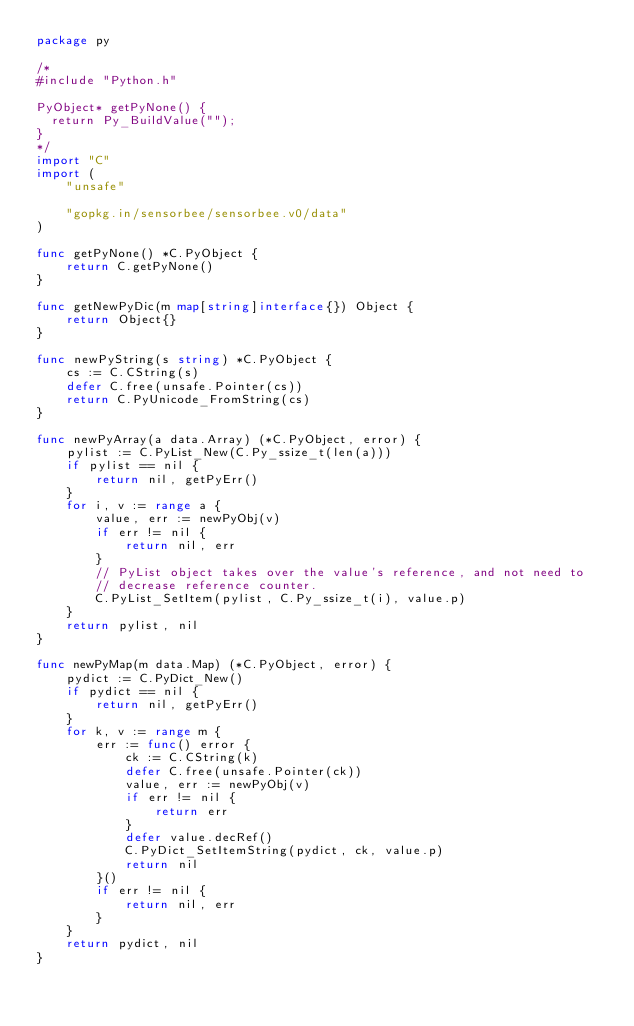<code> <loc_0><loc_0><loc_500><loc_500><_Go_>package py

/*
#include "Python.h"

PyObject* getPyNone() {
  return Py_BuildValue("");
}
*/
import "C"
import (
	"unsafe"

	"gopkg.in/sensorbee/sensorbee.v0/data"
)

func getPyNone() *C.PyObject {
	return C.getPyNone()
}

func getNewPyDic(m map[string]interface{}) Object {
	return Object{}
}

func newPyString(s string) *C.PyObject {
	cs := C.CString(s)
	defer C.free(unsafe.Pointer(cs))
	return C.PyUnicode_FromString(cs)
}

func newPyArray(a data.Array) (*C.PyObject, error) {
	pylist := C.PyList_New(C.Py_ssize_t(len(a)))
	if pylist == nil {
		return nil, getPyErr()
	}
	for i, v := range a {
		value, err := newPyObj(v)
		if err != nil {
			return nil, err
		}
		// PyList object takes over the value's reference, and not need to
		// decrease reference counter.
		C.PyList_SetItem(pylist, C.Py_ssize_t(i), value.p)
	}
	return pylist, nil
}

func newPyMap(m data.Map) (*C.PyObject, error) {
	pydict := C.PyDict_New()
	if pydict == nil {
		return nil, getPyErr()
	}
	for k, v := range m {
		err := func() error {
			ck := C.CString(k)
			defer C.free(unsafe.Pointer(ck))
			value, err := newPyObj(v)
			if err != nil {
				return err
			}
			defer value.decRef()
			C.PyDict_SetItemString(pydict, ck, value.p)
			return nil
		}()
		if err != nil {
			return nil, err
		}
	}
	return pydict, nil
}
</code> 